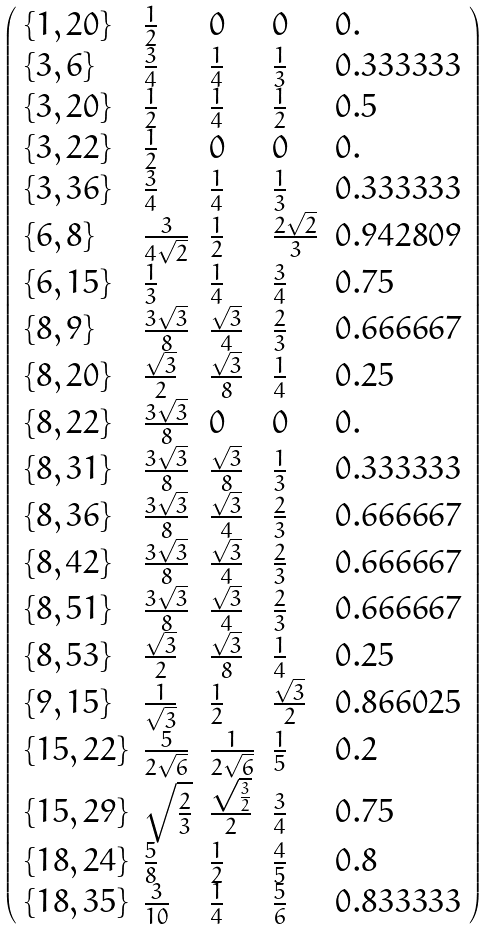Convert formula to latex. <formula><loc_0><loc_0><loc_500><loc_500>\left ( \begin{array} { l l l l l } \{ 1 , 2 0 \} & \frac { 1 } { 2 } & 0 & 0 & 0 . \\ \{ 3 , 6 \} & \frac { 3 } { 4 } & \frac { 1 } { 4 } & \frac { 1 } { 3 } & 0 . 3 3 3 3 3 3 \\ \{ 3 , 2 0 \} & \frac { 1 } { 2 } & \frac { 1 } { 4 } & \frac { 1 } { 2 } & 0 . 5 \\ \{ 3 , 2 2 \} & \frac { 1 } { 2 } & 0 & 0 & 0 . \\ \{ 3 , 3 6 \} & \frac { 3 } { 4 } & \frac { 1 } { 4 } & \frac { 1 } { 3 } & 0 . 3 3 3 3 3 3 \\ \{ 6 , 8 \} & \frac { 3 } { 4 \sqrt { 2 } } & \frac { 1 } { 2 } & \frac { 2 \sqrt { 2 } } { 3 } & 0 . 9 4 2 8 0 9 \\ \{ 6 , 1 5 \} & \frac { 1 } { 3 } & \frac { 1 } { 4 } & \frac { 3 } { 4 } & 0 . 7 5 \\ \{ 8 , 9 \} & \frac { 3 \sqrt { 3 } } { 8 } & \frac { \sqrt { 3 } } { 4 } & \frac { 2 } { 3 } & 0 . 6 6 6 6 6 7 \\ \{ 8 , 2 0 \} & \frac { \sqrt { 3 } } { 2 } & \frac { \sqrt { 3 } } { 8 } & \frac { 1 } { 4 } & 0 . 2 5 \\ \{ 8 , 2 2 \} & \frac { 3 \sqrt { 3 } } { 8 } & 0 & 0 & 0 . \\ \{ 8 , 3 1 \} & \frac { 3 \sqrt { 3 } } { 8 } & \frac { \sqrt { 3 } } { 8 } & \frac { 1 } { 3 } & 0 . 3 3 3 3 3 3 \\ \{ 8 , 3 6 \} & \frac { 3 \sqrt { 3 } } { 8 } & \frac { \sqrt { 3 } } { 4 } & \frac { 2 } { 3 } & 0 . 6 6 6 6 6 7 \\ \{ 8 , 4 2 \} & \frac { 3 \sqrt { 3 } } { 8 } & \frac { \sqrt { 3 } } { 4 } & \frac { 2 } { 3 } & 0 . 6 6 6 6 6 7 \\ \{ 8 , 5 1 \} & \frac { 3 \sqrt { 3 } } { 8 } & \frac { \sqrt { 3 } } { 4 } & \frac { 2 } { 3 } & 0 . 6 6 6 6 6 7 \\ \{ 8 , 5 3 \} & \frac { \sqrt { 3 } } { 2 } & \frac { \sqrt { 3 } } { 8 } & \frac { 1 } { 4 } & 0 . 2 5 \\ \{ 9 , 1 5 \} & \frac { 1 } { \sqrt { 3 } } & \frac { 1 } { 2 } & \frac { \sqrt { 3 } } { 2 } & 0 . 8 6 6 0 2 5 \\ \{ 1 5 , 2 2 \} & \frac { 5 } { 2 \sqrt { 6 } } & \frac { 1 } { 2 \sqrt { 6 } } & \frac { 1 } { 5 } & 0 . 2 \\ \{ 1 5 , 2 9 \} & \sqrt { \frac { 2 } { 3 } } & \frac { \sqrt { \frac { 3 } { 2 } } } { 2 } & \frac { 3 } { 4 } & 0 . 7 5 \\ \{ 1 8 , 2 4 \} & \frac { 5 } { 8 } & \frac { 1 } { 2 } & \frac { 4 } { 5 } & 0 . 8 \\ \{ 1 8 , 3 5 \} & \frac { 3 } { 1 0 } & \frac { 1 } { 4 } & \frac { 5 } { 6 } & 0 . 8 3 3 3 3 3 \end{array} \right )</formula> 